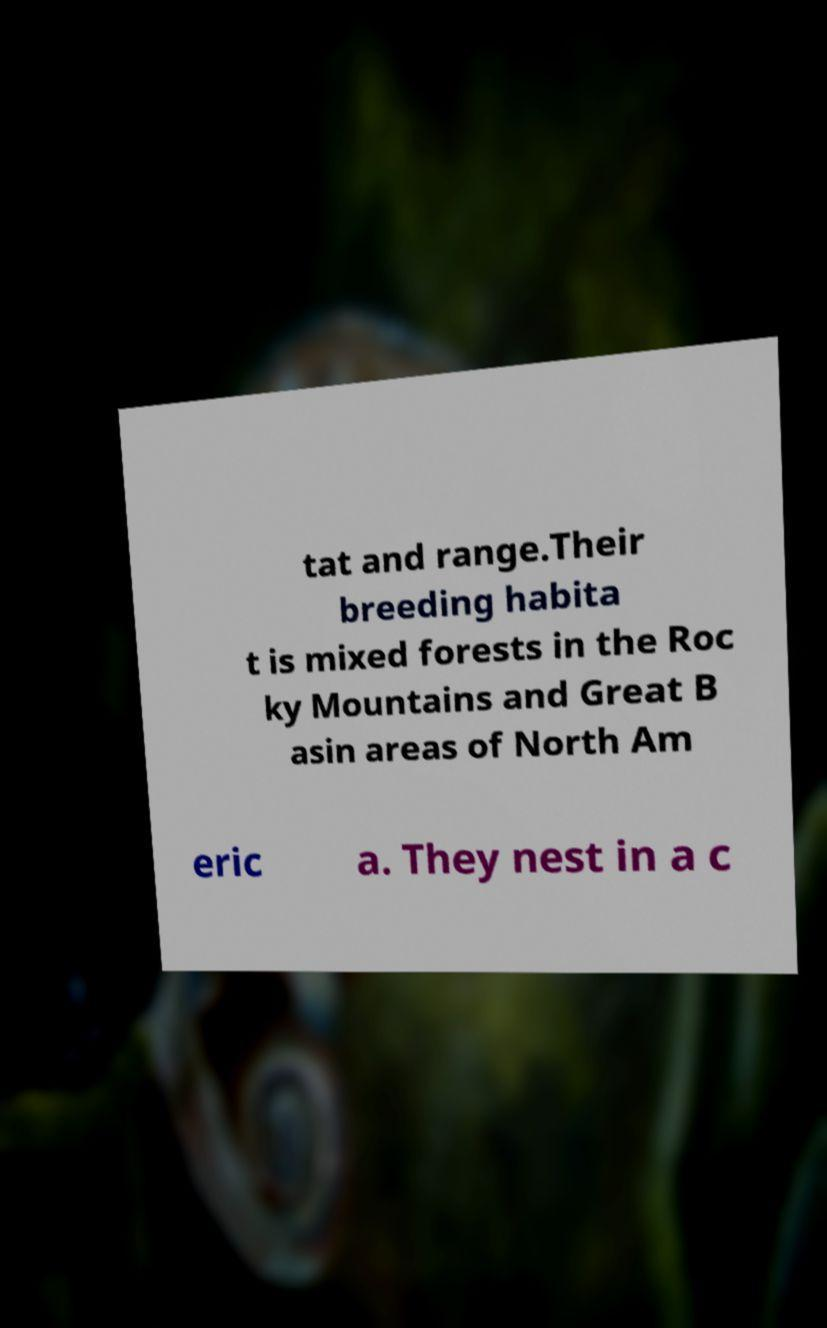Please identify and transcribe the text found in this image. tat and range.Their breeding habita t is mixed forests in the Roc ky Mountains and Great B asin areas of North Am eric a. They nest in a c 